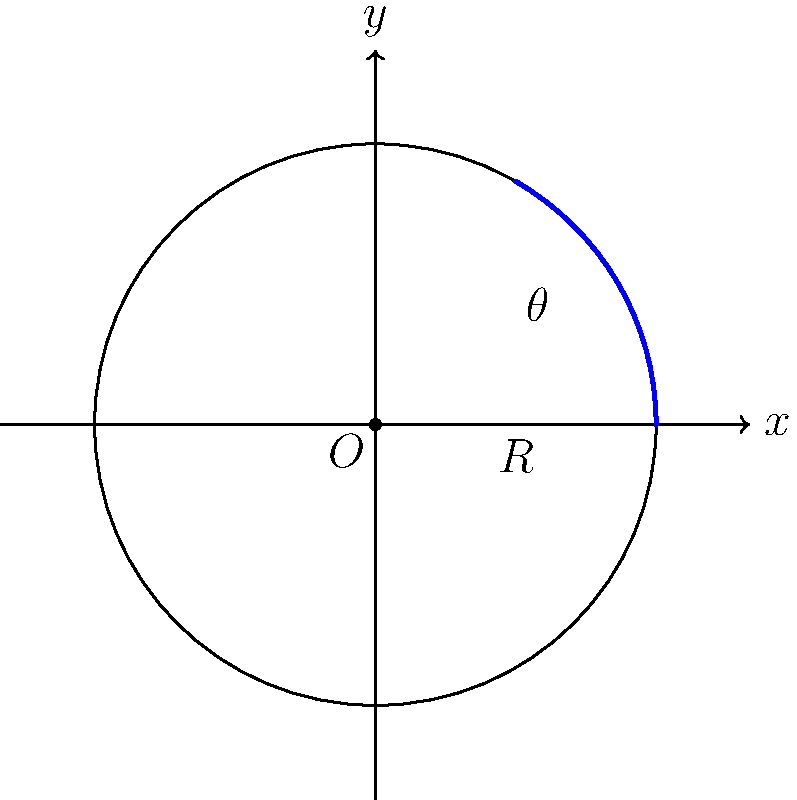On a negatively curved surface (like a saddle shape), the circumference of a circle is larger than $2\pi r$, where $r$ is the radius. Suppose you're helping your child understand this concept using a toy model. If the circumference of a circle with radius 5 cm on this surface is 40 cm, what is the ratio of this circumference to the circumference of a circle with the same radius on a flat plane? Round your answer to two decimal places. Let's approach this step-by-step:

1) First, let's recall the formula for the circumference of a circle on a flat (Euclidean) plane:
   $$C = 2\pi r$$

2) For the given radius of 5 cm on a flat plane, the circumference would be:
   $$C_{flat} = 2\pi (5) = 10\pi \approx 31.42 \text{ cm}$$

3) However, we're told that on this negatively curved surface, the actual circumference is 40 cm.

4) To find the ratio, we divide the actual circumference by the Euclidean circumference:
   $$\text{Ratio} = \frac{C_{curved}}{C_{flat}} = \frac{40}{10\pi}$$

5) Let's calculate this:
   $$\frac{40}{10\pi} \approx 1.2732$$

6) Rounding to two decimal places:
   $$1.27$$

This ratio shows that the circumference on the negatively curved surface is about 1.27 times larger than it would be on a flat surface.
Answer: 1.27 